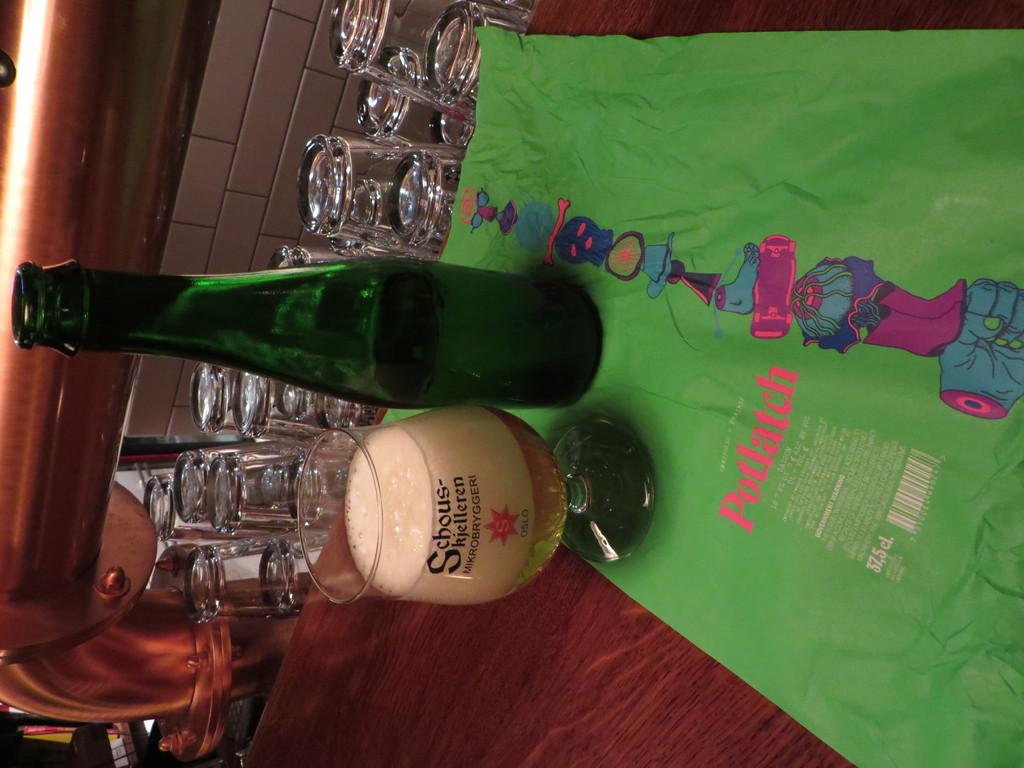Provide a one-sentence caption for the provided image. a sidways view of a green bottle and a glass of beer with the word potlatch on a green cloth. 